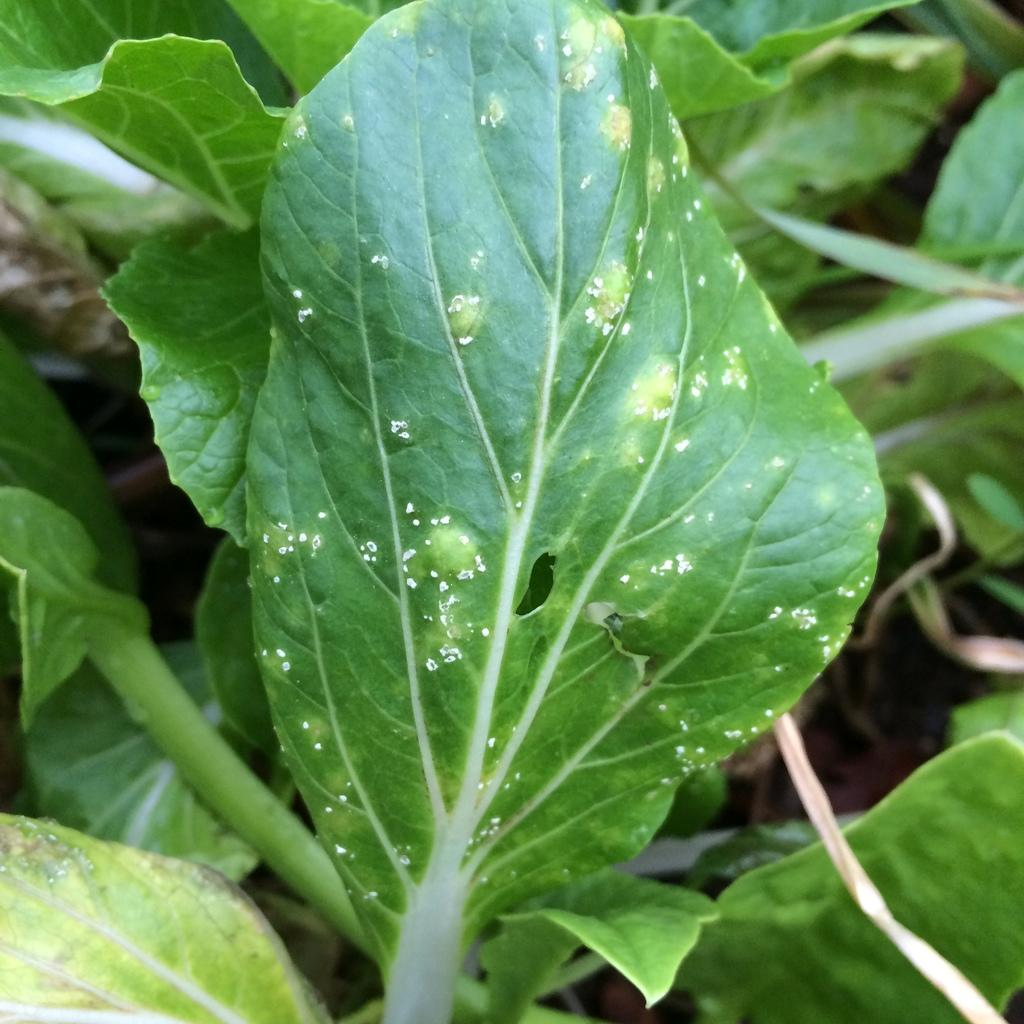What type of plant parts are visible in the image? There are leaves of a plant in the image. Can you describe the plant based on the visible leaves? The leaves belong to a plant, but the specific type of plant cannot be determined from the image alone. What type of furniture is being used in the class depicted in the image? There is no furniture or class present in the image; it only features leaves of a plant. 